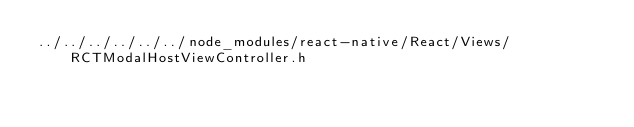<code> <loc_0><loc_0><loc_500><loc_500><_C_>../../../../../../node_modules/react-native/React/Views/RCTModalHostViewController.h</code> 